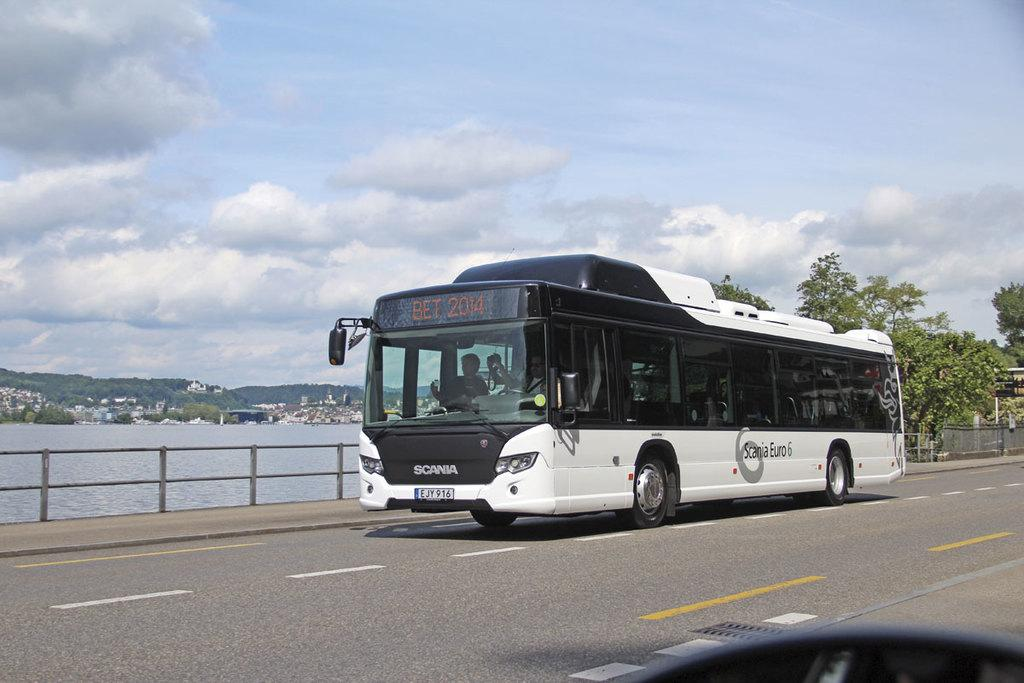What is the main subject of the image? The main subject of the image is a bus moving on the road. What can be seen in the background of the image? The sky is cloudy in the background of the image. What type of natural elements are present in the image? There are trees and water visible in the image. What architectural feature can be seen in the image? There is a fence in the image. How many rings are visible on the bus in the image? There are no rings visible on the bus in the image. What type of cemetery can be seen in the image? There is no cemetery present in the image. 